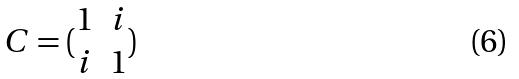Convert formula to latex. <formula><loc_0><loc_0><loc_500><loc_500>C = ( \begin{matrix} 1 & i \\ i & 1 \end{matrix} )</formula> 